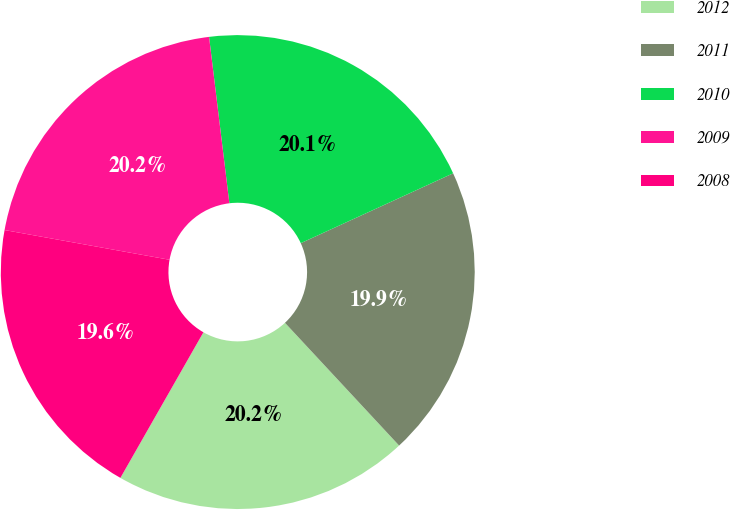Convert chart to OTSL. <chart><loc_0><loc_0><loc_500><loc_500><pie_chart><fcel>2012<fcel>2011<fcel>2010<fcel>2009<fcel>2008<nl><fcel>20.17%<fcel>19.92%<fcel>20.09%<fcel>20.23%<fcel>19.59%<nl></chart> 